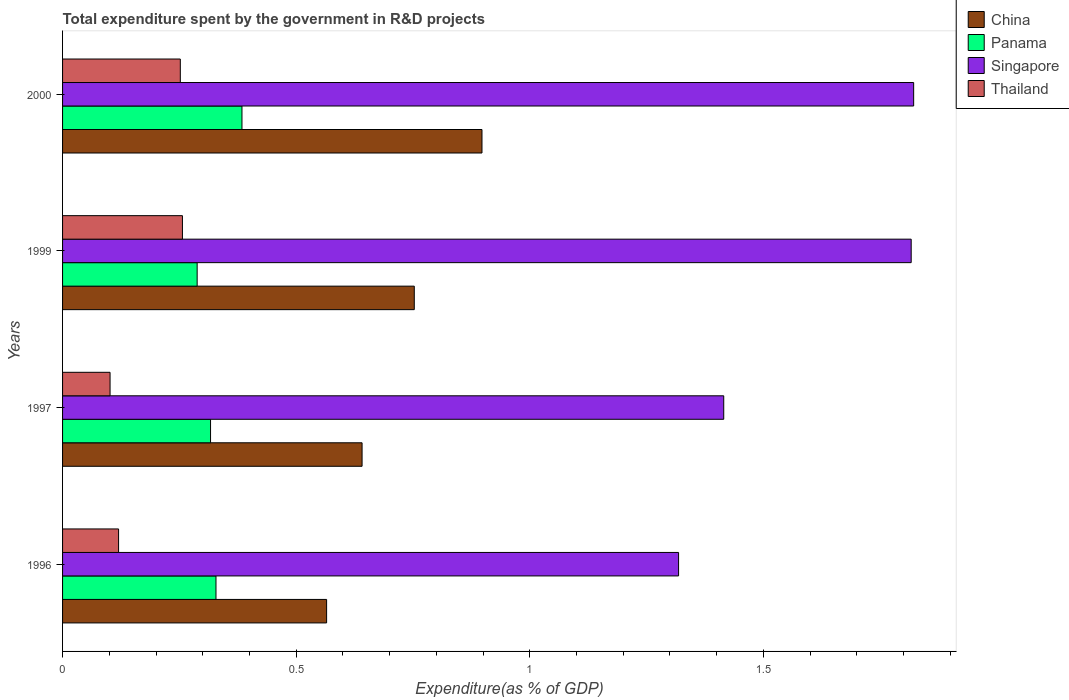How many different coloured bars are there?
Offer a terse response. 4. How many groups of bars are there?
Your answer should be very brief. 4. Are the number of bars on each tick of the Y-axis equal?
Provide a short and direct response. Yes. How many bars are there on the 3rd tick from the top?
Your answer should be very brief. 4. What is the label of the 3rd group of bars from the top?
Offer a terse response. 1997. In how many cases, is the number of bars for a given year not equal to the number of legend labels?
Offer a terse response. 0. What is the total expenditure spent by the government in R&D projects in Panama in 2000?
Your answer should be compact. 0.38. Across all years, what is the maximum total expenditure spent by the government in R&D projects in China?
Ensure brevity in your answer.  0.9. Across all years, what is the minimum total expenditure spent by the government in R&D projects in Singapore?
Offer a terse response. 1.32. What is the total total expenditure spent by the government in R&D projects in Singapore in the graph?
Offer a terse response. 6.37. What is the difference between the total expenditure spent by the government in R&D projects in Thailand in 1997 and that in 2000?
Provide a short and direct response. -0.15. What is the difference between the total expenditure spent by the government in R&D projects in China in 1996 and the total expenditure spent by the government in R&D projects in Singapore in 2000?
Provide a short and direct response. -1.26. What is the average total expenditure spent by the government in R&D projects in Singapore per year?
Keep it short and to the point. 1.59. In the year 2000, what is the difference between the total expenditure spent by the government in R&D projects in Panama and total expenditure spent by the government in R&D projects in China?
Make the answer very short. -0.51. In how many years, is the total expenditure spent by the government in R&D projects in Thailand greater than 1.4 %?
Offer a terse response. 0. What is the ratio of the total expenditure spent by the government in R&D projects in Thailand in 1996 to that in 1999?
Your response must be concise. 0.47. Is the difference between the total expenditure spent by the government in R&D projects in Panama in 1999 and 2000 greater than the difference between the total expenditure spent by the government in R&D projects in China in 1999 and 2000?
Make the answer very short. Yes. What is the difference between the highest and the second highest total expenditure spent by the government in R&D projects in Thailand?
Your answer should be compact. 0. What is the difference between the highest and the lowest total expenditure spent by the government in R&D projects in China?
Provide a succinct answer. 0.33. In how many years, is the total expenditure spent by the government in R&D projects in Thailand greater than the average total expenditure spent by the government in R&D projects in Thailand taken over all years?
Offer a terse response. 2. Is the sum of the total expenditure spent by the government in R&D projects in Thailand in 1997 and 1999 greater than the maximum total expenditure spent by the government in R&D projects in Singapore across all years?
Make the answer very short. No. What does the 1st bar from the bottom in 1996 represents?
Provide a short and direct response. China. Is it the case that in every year, the sum of the total expenditure spent by the government in R&D projects in China and total expenditure spent by the government in R&D projects in Panama is greater than the total expenditure spent by the government in R&D projects in Thailand?
Keep it short and to the point. Yes. How many years are there in the graph?
Your answer should be compact. 4. What is the difference between two consecutive major ticks on the X-axis?
Keep it short and to the point. 0.5. Are the values on the major ticks of X-axis written in scientific E-notation?
Give a very brief answer. No. Does the graph contain any zero values?
Your answer should be very brief. No. Does the graph contain grids?
Offer a very short reply. No. What is the title of the graph?
Ensure brevity in your answer.  Total expenditure spent by the government in R&D projects. Does "Seychelles" appear as one of the legend labels in the graph?
Offer a terse response. No. What is the label or title of the X-axis?
Your response must be concise. Expenditure(as % of GDP). What is the label or title of the Y-axis?
Ensure brevity in your answer.  Years. What is the Expenditure(as % of GDP) of China in 1996?
Offer a very short reply. 0.57. What is the Expenditure(as % of GDP) in Panama in 1996?
Keep it short and to the point. 0.33. What is the Expenditure(as % of GDP) of Singapore in 1996?
Provide a succinct answer. 1.32. What is the Expenditure(as % of GDP) of Thailand in 1996?
Keep it short and to the point. 0.12. What is the Expenditure(as % of GDP) of China in 1997?
Your answer should be compact. 0.64. What is the Expenditure(as % of GDP) in Panama in 1997?
Provide a succinct answer. 0.32. What is the Expenditure(as % of GDP) of Singapore in 1997?
Offer a terse response. 1.42. What is the Expenditure(as % of GDP) in Thailand in 1997?
Your answer should be very brief. 0.1. What is the Expenditure(as % of GDP) in China in 1999?
Provide a short and direct response. 0.75. What is the Expenditure(as % of GDP) of Panama in 1999?
Your response must be concise. 0.29. What is the Expenditure(as % of GDP) in Singapore in 1999?
Offer a terse response. 1.82. What is the Expenditure(as % of GDP) in Thailand in 1999?
Provide a succinct answer. 0.26. What is the Expenditure(as % of GDP) of China in 2000?
Offer a terse response. 0.9. What is the Expenditure(as % of GDP) of Panama in 2000?
Provide a succinct answer. 0.38. What is the Expenditure(as % of GDP) in Singapore in 2000?
Offer a very short reply. 1.82. What is the Expenditure(as % of GDP) of Thailand in 2000?
Your response must be concise. 0.25. Across all years, what is the maximum Expenditure(as % of GDP) of China?
Give a very brief answer. 0.9. Across all years, what is the maximum Expenditure(as % of GDP) in Panama?
Your answer should be very brief. 0.38. Across all years, what is the maximum Expenditure(as % of GDP) in Singapore?
Offer a terse response. 1.82. Across all years, what is the maximum Expenditure(as % of GDP) of Thailand?
Your answer should be very brief. 0.26. Across all years, what is the minimum Expenditure(as % of GDP) in China?
Keep it short and to the point. 0.57. Across all years, what is the minimum Expenditure(as % of GDP) in Panama?
Give a very brief answer. 0.29. Across all years, what is the minimum Expenditure(as % of GDP) in Singapore?
Offer a very short reply. 1.32. Across all years, what is the minimum Expenditure(as % of GDP) of Thailand?
Your answer should be very brief. 0.1. What is the total Expenditure(as % of GDP) of China in the graph?
Provide a short and direct response. 2.86. What is the total Expenditure(as % of GDP) in Panama in the graph?
Provide a succinct answer. 1.32. What is the total Expenditure(as % of GDP) of Singapore in the graph?
Your answer should be very brief. 6.37. What is the total Expenditure(as % of GDP) in Thailand in the graph?
Offer a very short reply. 0.73. What is the difference between the Expenditure(as % of GDP) in China in 1996 and that in 1997?
Your answer should be compact. -0.08. What is the difference between the Expenditure(as % of GDP) in Panama in 1996 and that in 1997?
Make the answer very short. 0.01. What is the difference between the Expenditure(as % of GDP) of Singapore in 1996 and that in 1997?
Provide a succinct answer. -0.1. What is the difference between the Expenditure(as % of GDP) in Thailand in 1996 and that in 1997?
Offer a terse response. 0.02. What is the difference between the Expenditure(as % of GDP) of China in 1996 and that in 1999?
Your answer should be very brief. -0.19. What is the difference between the Expenditure(as % of GDP) in Panama in 1996 and that in 1999?
Provide a short and direct response. 0.04. What is the difference between the Expenditure(as % of GDP) in Singapore in 1996 and that in 1999?
Give a very brief answer. -0.5. What is the difference between the Expenditure(as % of GDP) in Thailand in 1996 and that in 1999?
Provide a succinct answer. -0.14. What is the difference between the Expenditure(as % of GDP) of China in 1996 and that in 2000?
Ensure brevity in your answer.  -0.33. What is the difference between the Expenditure(as % of GDP) of Panama in 1996 and that in 2000?
Provide a short and direct response. -0.06. What is the difference between the Expenditure(as % of GDP) in Singapore in 1996 and that in 2000?
Your response must be concise. -0.5. What is the difference between the Expenditure(as % of GDP) in Thailand in 1996 and that in 2000?
Ensure brevity in your answer.  -0.13. What is the difference between the Expenditure(as % of GDP) in China in 1997 and that in 1999?
Your response must be concise. -0.11. What is the difference between the Expenditure(as % of GDP) in Panama in 1997 and that in 1999?
Make the answer very short. 0.03. What is the difference between the Expenditure(as % of GDP) of Singapore in 1997 and that in 1999?
Give a very brief answer. -0.4. What is the difference between the Expenditure(as % of GDP) in Thailand in 1997 and that in 1999?
Your response must be concise. -0.15. What is the difference between the Expenditure(as % of GDP) in China in 1997 and that in 2000?
Keep it short and to the point. -0.26. What is the difference between the Expenditure(as % of GDP) of Panama in 1997 and that in 2000?
Your answer should be very brief. -0.07. What is the difference between the Expenditure(as % of GDP) in Singapore in 1997 and that in 2000?
Your answer should be very brief. -0.41. What is the difference between the Expenditure(as % of GDP) in Thailand in 1997 and that in 2000?
Your answer should be compact. -0.15. What is the difference between the Expenditure(as % of GDP) of China in 1999 and that in 2000?
Your answer should be compact. -0.14. What is the difference between the Expenditure(as % of GDP) of Panama in 1999 and that in 2000?
Offer a terse response. -0.1. What is the difference between the Expenditure(as % of GDP) in Singapore in 1999 and that in 2000?
Your answer should be compact. -0.01. What is the difference between the Expenditure(as % of GDP) in Thailand in 1999 and that in 2000?
Offer a very short reply. 0. What is the difference between the Expenditure(as % of GDP) in China in 1996 and the Expenditure(as % of GDP) in Panama in 1997?
Provide a short and direct response. 0.25. What is the difference between the Expenditure(as % of GDP) in China in 1996 and the Expenditure(as % of GDP) in Singapore in 1997?
Make the answer very short. -0.85. What is the difference between the Expenditure(as % of GDP) of China in 1996 and the Expenditure(as % of GDP) of Thailand in 1997?
Provide a succinct answer. 0.46. What is the difference between the Expenditure(as % of GDP) of Panama in 1996 and the Expenditure(as % of GDP) of Singapore in 1997?
Provide a short and direct response. -1.09. What is the difference between the Expenditure(as % of GDP) of Panama in 1996 and the Expenditure(as % of GDP) of Thailand in 1997?
Give a very brief answer. 0.23. What is the difference between the Expenditure(as % of GDP) of Singapore in 1996 and the Expenditure(as % of GDP) of Thailand in 1997?
Your answer should be compact. 1.22. What is the difference between the Expenditure(as % of GDP) of China in 1996 and the Expenditure(as % of GDP) of Panama in 1999?
Ensure brevity in your answer.  0.28. What is the difference between the Expenditure(as % of GDP) of China in 1996 and the Expenditure(as % of GDP) of Singapore in 1999?
Offer a very short reply. -1.25. What is the difference between the Expenditure(as % of GDP) of China in 1996 and the Expenditure(as % of GDP) of Thailand in 1999?
Ensure brevity in your answer.  0.31. What is the difference between the Expenditure(as % of GDP) of Panama in 1996 and the Expenditure(as % of GDP) of Singapore in 1999?
Provide a succinct answer. -1.49. What is the difference between the Expenditure(as % of GDP) in Panama in 1996 and the Expenditure(as % of GDP) in Thailand in 1999?
Your response must be concise. 0.07. What is the difference between the Expenditure(as % of GDP) in Singapore in 1996 and the Expenditure(as % of GDP) in Thailand in 1999?
Offer a terse response. 1.06. What is the difference between the Expenditure(as % of GDP) of China in 1996 and the Expenditure(as % of GDP) of Panama in 2000?
Give a very brief answer. 0.18. What is the difference between the Expenditure(as % of GDP) of China in 1996 and the Expenditure(as % of GDP) of Singapore in 2000?
Your response must be concise. -1.26. What is the difference between the Expenditure(as % of GDP) of China in 1996 and the Expenditure(as % of GDP) of Thailand in 2000?
Your response must be concise. 0.31. What is the difference between the Expenditure(as % of GDP) of Panama in 1996 and the Expenditure(as % of GDP) of Singapore in 2000?
Your answer should be compact. -1.49. What is the difference between the Expenditure(as % of GDP) in Panama in 1996 and the Expenditure(as % of GDP) in Thailand in 2000?
Ensure brevity in your answer.  0.08. What is the difference between the Expenditure(as % of GDP) of Singapore in 1996 and the Expenditure(as % of GDP) of Thailand in 2000?
Offer a very short reply. 1.07. What is the difference between the Expenditure(as % of GDP) of China in 1997 and the Expenditure(as % of GDP) of Panama in 1999?
Give a very brief answer. 0.35. What is the difference between the Expenditure(as % of GDP) in China in 1997 and the Expenditure(as % of GDP) in Singapore in 1999?
Provide a succinct answer. -1.18. What is the difference between the Expenditure(as % of GDP) of China in 1997 and the Expenditure(as % of GDP) of Thailand in 1999?
Offer a very short reply. 0.38. What is the difference between the Expenditure(as % of GDP) of Panama in 1997 and the Expenditure(as % of GDP) of Singapore in 1999?
Ensure brevity in your answer.  -1.5. What is the difference between the Expenditure(as % of GDP) in Panama in 1997 and the Expenditure(as % of GDP) in Thailand in 1999?
Make the answer very short. 0.06. What is the difference between the Expenditure(as % of GDP) in Singapore in 1997 and the Expenditure(as % of GDP) in Thailand in 1999?
Provide a succinct answer. 1.16. What is the difference between the Expenditure(as % of GDP) in China in 1997 and the Expenditure(as % of GDP) in Panama in 2000?
Provide a succinct answer. 0.26. What is the difference between the Expenditure(as % of GDP) in China in 1997 and the Expenditure(as % of GDP) in Singapore in 2000?
Give a very brief answer. -1.18. What is the difference between the Expenditure(as % of GDP) in China in 1997 and the Expenditure(as % of GDP) in Thailand in 2000?
Keep it short and to the point. 0.39. What is the difference between the Expenditure(as % of GDP) in Panama in 1997 and the Expenditure(as % of GDP) in Singapore in 2000?
Give a very brief answer. -1.5. What is the difference between the Expenditure(as % of GDP) in Panama in 1997 and the Expenditure(as % of GDP) in Thailand in 2000?
Your answer should be very brief. 0.06. What is the difference between the Expenditure(as % of GDP) of Singapore in 1997 and the Expenditure(as % of GDP) of Thailand in 2000?
Make the answer very short. 1.16. What is the difference between the Expenditure(as % of GDP) in China in 1999 and the Expenditure(as % of GDP) in Panama in 2000?
Provide a short and direct response. 0.37. What is the difference between the Expenditure(as % of GDP) in China in 1999 and the Expenditure(as % of GDP) in Singapore in 2000?
Provide a succinct answer. -1.07. What is the difference between the Expenditure(as % of GDP) of China in 1999 and the Expenditure(as % of GDP) of Thailand in 2000?
Offer a terse response. 0.5. What is the difference between the Expenditure(as % of GDP) of Panama in 1999 and the Expenditure(as % of GDP) of Singapore in 2000?
Make the answer very short. -1.53. What is the difference between the Expenditure(as % of GDP) of Panama in 1999 and the Expenditure(as % of GDP) of Thailand in 2000?
Ensure brevity in your answer.  0.04. What is the difference between the Expenditure(as % of GDP) of Singapore in 1999 and the Expenditure(as % of GDP) of Thailand in 2000?
Provide a succinct answer. 1.56. What is the average Expenditure(as % of GDP) of China per year?
Your response must be concise. 0.71. What is the average Expenditure(as % of GDP) of Panama per year?
Give a very brief answer. 0.33. What is the average Expenditure(as % of GDP) of Singapore per year?
Make the answer very short. 1.59. What is the average Expenditure(as % of GDP) of Thailand per year?
Provide a short and direct response. 0.18. In the year 1996, what is the difference between the Expenditure(as % of GDP) in China and Expenditure(as % of GDP) in Panama?
Ensure brevity in your answer.  0.24. In the year 1996, what is the difference between the Expenditure(as % of GDP) in China and Expenditure(as % of GDP) in Singapore?
Give a very brief answer. -0.75. In the year 1996, what is the difference between the Expenditure(as % of GDP) of China and Expenditure(as % of GDP) of Thailand?
Provide a succinct answer. 0.45. In the year 1996, what is the difference between the Expenditure(as % of GDP) in Panama and Expenditure(as % of GDP) in Singapore?
Provide a short and direct response. -0.99. In the year 1996, what is the difference between the Expenditure(as % of GDP) in Panama and Expenditure(as % of GDP) in Thailand?
Make the answer very short. 0.21. In the year 1996, what is the difference between the Expenditure(as % of GDP) of Singapore and Expenditure(as % of GDP) of Thailand?
Give a very brief answer. 1.2. In the year 1997, what is the difference between the Expenditure(as % of GDP) of China and Expenditure(as % of GDP) of Panama?
Make the answer very short. 0.32. In the year 1997, what is the difference between the Expenditure(as % of GDP) of China and Expenditure(as % of GDP) of Singapore?
Give a very brief answer. -0.77. In the year 1997, what is the difference between the Expenditure(as % of GDP) in China and Expenditure(as % of GDP) in Thailand?
Offer a very short reply. 0.54. In the year 1997, what is the difference between the Expenditure(as % of GDP) in Panama and Expenditure(as % of GDP) in Singapore?
Give a very brief answer. -1.1. In the year 1997, what is the difference between the Expenditure(as % of GDP) of Panama and Expenditure(as % of GDP) of Thailand?
Give a very brief answer. 0.21. In the year 1997, what is the difference between the Expenditure(as % of GDP) of Singapore and Expenditure(as % of GDP) of Thailand?
Your response must be concise. 1.31. In the year 1999, what is the difference between the Expenditure(as % of GDP) of China and Expenditure(as % of GDP) of Panama?
Your response must be concise. 0.46. In the year 1999, what is the difference between the Expenditure(as % of GDP) of China and Expenditure(as % of GDP) of Singapore?
Provide a succinct answer. -1.06. In the year 1999, what is the difference between the Expenditure(as % of GDP) in China and Expenditure(as % of GDP) in Thailand?
Your answer should be compact. 0.5. In the year 1999, what is the difference between the Expenditure(as % of GDP) in Panama and Expenditure(as % of GDP) in Singapore?
Give a very brief answer. -1.53. In the year 1999, what is the difference between the Expenditure(as % of GDP) in Panama and Expenditure(as % of GDP) in Thailand?
Provide a succinct answer. 0.03. In the year 1999, what is the difference between the Expenditure(as % of GDP) in Singapore and Expenditure(as % of GDP) in Thailand?
Your response must be concise. 1.56. In the year 2000, what is the difference between the Expenditure(as % of GDP) of China and Expenditure(as % of GDP) of Panama?
Offer a terse response. 0.51. In the year 2000, what is the difference between the Expenditure(as % of GDP) of China and Expenditure(as % of GDP) of Singapore?
Ensure brevity in your answer.  -0.92. In the year 2000, what is the difference between the Expenditure(as % of GDP) in China and Expenditure(as % of GDP) in Thailand?
Your answer should be very brief. 0.65. In the year 2000, what is the difference between the Expenditure(as % of GDP) of Panama and Expenditure(as % of GDP) of Singapore?
Make the answer very short. -1.44. In the year 2000, what is the difference between the Expenditure(as % of GDP) of Panama and Expenditure(as % of GDP) of Thailand?
Your response must be concise. 0.13. In the year 2000, what is the difference between the Expenditure(as % of GDP) of Singapore and Expenditure(as % of GDP) of Thailand?
Your answer should be compact. 1.57. What is the ratio of the Expenditure(as % of GDP) of China in 1996 to that in 1997?
Your answer should be very brief. 0.88. What is the ratio of the Expenditure(as % of GDP) of Panama in 1996 to that in 1997?
Your answer should be very brief. 1.04. What is the ratio of the Expenditure(as % of GDP) in Singapore in 1996 to that in 1997?
Your response must be concise. 0.93. What is the ratio of the Expenditure(as % of GDP) of Thailand in 1996 to that in 1997?
Offer a terse response. 1.18. What is the ratio of the Expenditure(as % of GDP) of China in 1996 to that in 1999?
Your response must be concise. 0.75. What is the ratio of the Expenditure(as % of GDP) of Panama in 1996 to that in 1999?
Keep it short and to the point. 1.14. What is the ratio of the Expenditure(as % of GDP) of Singapore in 1996 to that in 1999?
Keep it short and to the point. 0.73. What is the ratio of the Expenditure(as % of GDP) of Thailand in 1996 to that in 1999?
Provide a succinct answer. 0.47. What is the ratio of the Expenditure(as % of GDP) of China in 1996 to that in 2000?
Keep it short and to the point. 0.63. What is the ratio of the Expenditure(as % of GDP) in Panama in 1996 to that in 2000?
Offer a terse response. 0.86. What is the ratio of the Expenditure(as % of GDP) of Singapore in 1996 to that in 2000?
Offer a very short reply. 0.72. What is the ratio of the Expenditure(as % of GDP) in Thailand in 1996 to that in 2000?
Make the answer very short. 0.48. What is the ratio of the Expenditure(as % of GDP) in China in 1997 to that in 1999?
Keep it short and to the point. 0.85. What is the ratio of the Expenditure(as % of GDP) in Panama in 1997 to that in 1999?
Your answer should be very brief. 1.1. What is the ratio of the Expenditure(as % of GDP) of Singapore in 1997 to that in 1999?
Ensure brevity in your answer.  0.78. What is the ratio of the Expenditure(as % of GDP) in Thailand in 1997 to that in 1999?
Offer a terse response. 0.4. What is the ratio of the Expenditure(as % of GDP) of China in 1997 to that in 2000?
Your answer should be very brief. 0.71. What is the ratio of the Expenditure(as % of GDP) of Panama in 1997 to that in 2000?
Keep it short and to the point. 0.82. What is the ratio of the Expenditure(as % of GDP) of Singapore in 1997 to that in 2000?
Offer a terse response. 0.78. What is the ratio of the Expenditure(as % of GDP) in Thailand in 1997 to that in 2000?
Make the answer very short. 0.4. What is the ratio of the Expenditure(as % of GDP) of China in 1999 to that in 2000?
Offer a very short reply. 0.84. What is the ratio of the Expenditure(as % of GDP) of Panama in 1999 to that in 2000?
Offer a very short reply. 0.75. What is the ratio of the Expenditure(as % of GDP) of Thailand in 1999 to that in 2000?
Offer a terse response. 1.02. What is the difference between the highest and the second highest Expenditure(as % of GDP) of China?
Make the answer very short. 0.14. What is the difference between the highest and the second highest Expenditure(as % of GDP) of Panama?
Your answer should be compact. 0.06. What is the difference between the highest and the second highest Expenditure(as % of GDP) in Singapore?
Your answer should be compact. 0.01. What is the difference between the highest and the second highest Expenditure(as % of GDP) in Thailand?
Make the answer very short. 0. What is the difference between the highest and the lowest Expenditure(as % of GDP) in China?
Your response must be concise. 0.33. What is the difference between the highest and the lowest Expenditure(as % of GDP) in Panama?
Your answer should be very brief. 0.1. What is the difference between the highest and the lowest Expenditure(as % of GDP) in Singapore?
Provide a short and direct response. 0.5. What is the difference between the highest and the lowest Expenditure(as % of GDP) in Thailand?
Keep it short and to the point. 0.15. 